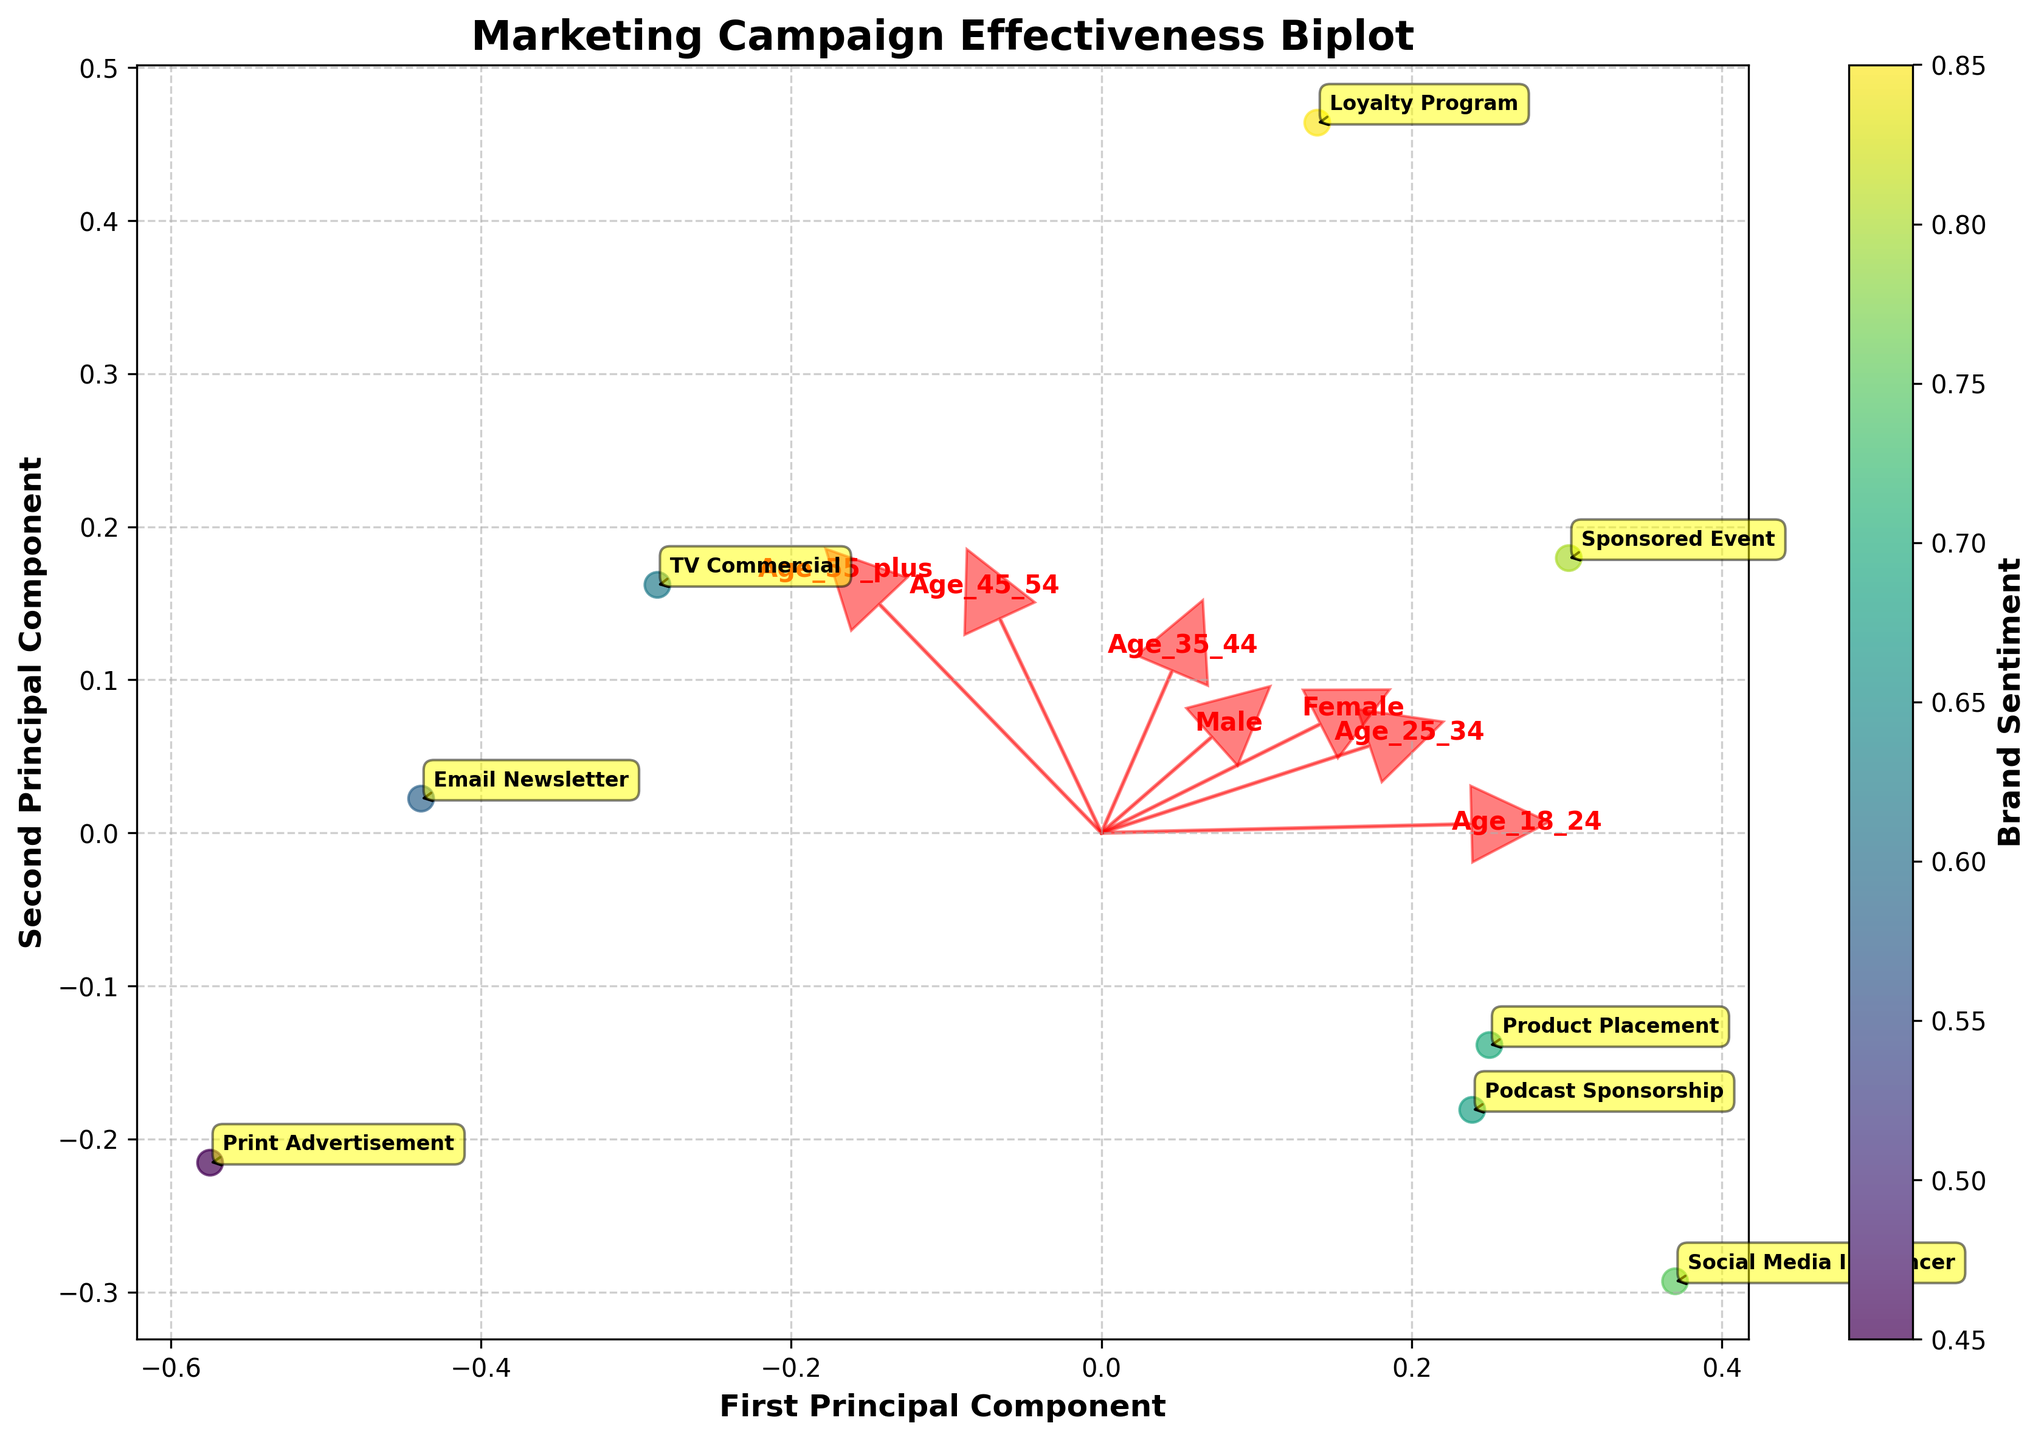What does the color indicate in the biplot? The colors in the biplot indicate the Brand Sentiment. The colorbar next to the plot shows the gradient from lower to higher Brand Sentiment values.
Answer: Brand Sentiment How many principal components are displayed in the biplot? The biplot displays two principal components, as it combines data from various demographics into two dimensions for easier visualization. This is evident from the X and Y axes labeled 'First Principal Component' and 'Second Principal Component'.
Answer: Two Which marketing campaign has the highest Brand Sentiment? The 'Sponsored Event' campaign is located in the region with the darkest color, indicating a high Brand Sentiment value as represented by the color gradient.
Answer: Sponsored Event Are demographics 'Age 18-24' and 'Age 55 plus' positively correlated or negatively correlated? The loading vectors for 'Age 18-24' and 'Age 55 plus' point in different directions, suggesting they are negatively correlated.
Answer: Negatively correlated Which demographic group seems to have the opposite trend compared to the 'Female' demographic? The 'Age 45-54' demographic loading vector points in the opposite direction to the 'Female' demographic vector, indicating an opposite trend.
Answer: Age 45-54 Which campaigns are closely associated with the 'Age 18-24' demographic? Campaigns like 'Social Media Influencer' and 'Sponsored Event' are positioned closer to the 'Age 18-24' vector, indicating higher association with this demographic.
Answer: Social Media Influencer, Sponsored Event What can you infer about the 'Loyalty Program' from its biplot position? The 'Loyalty Program' is located far from the origin and lies near the direction where both the 'Age 45-54' and 'Male' vectors point, indicating a high association with these demographics and high Brand Sentiment.
Answer: High association with Age 45-54 and Male, high Brand Sentiment Compare the Brand Sentiment of 'TV Commercial' and 'Print Advertisement'. 'TV Commercial' is plotted in a lighter shade compared to 'Print Advertisement', indicating it has a higher Brand Sentiment value.
Answer: TV Commercial has higher Brand Sentiment Between 'Product Placement' and 'Email Newsletter', which campaign shows higher effectiveness for the 'Age 25-34' demographic? 'Product Placement' is plotted closer to the 'Age 25-34' demographic vector than 'Email Newsletter', indicating higher effectiveness for this demographic.
Answer: Product Placement What is the relationship between the 'Age 35-44' demographic and 'Podcast Sponsorship' campaign? 'Podcast Sponsorship' is located closer to the 'Age 35-44' vector, indicating a strong relationship between the campaign and the demographic group.
Answer: Strong relationship 